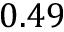Convert formula to latex. <formula><loc_0><loc_0><loc_500><loc_500>0 . 4 9</formula> 